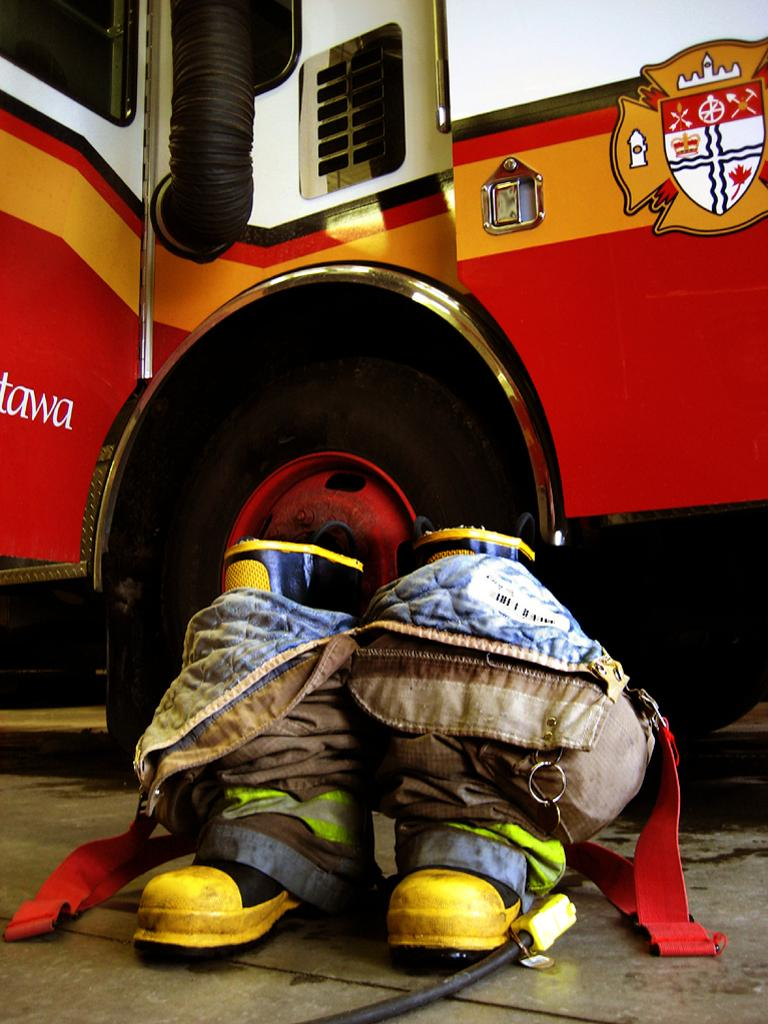What part of a vehicle is visible in the image? There is a part of a truck in the image. What feature of the truck can be seen? The truck has a wheel. What type of footwear is on the floor in the image? There is a pair of yellow shoes on the floor. Is there anything attached to the shoes? Yes, there is a bag tied to the shoes. What type of stem can be seen growing from the truck in the image? There is no stem growing from the truck in the image. What does the crook believe about the truck in the image? There is no crook or belief mentioned in the image; it only shows a part of a truck, a wheel, yellow shoes, and a bag tied to the shoes. 